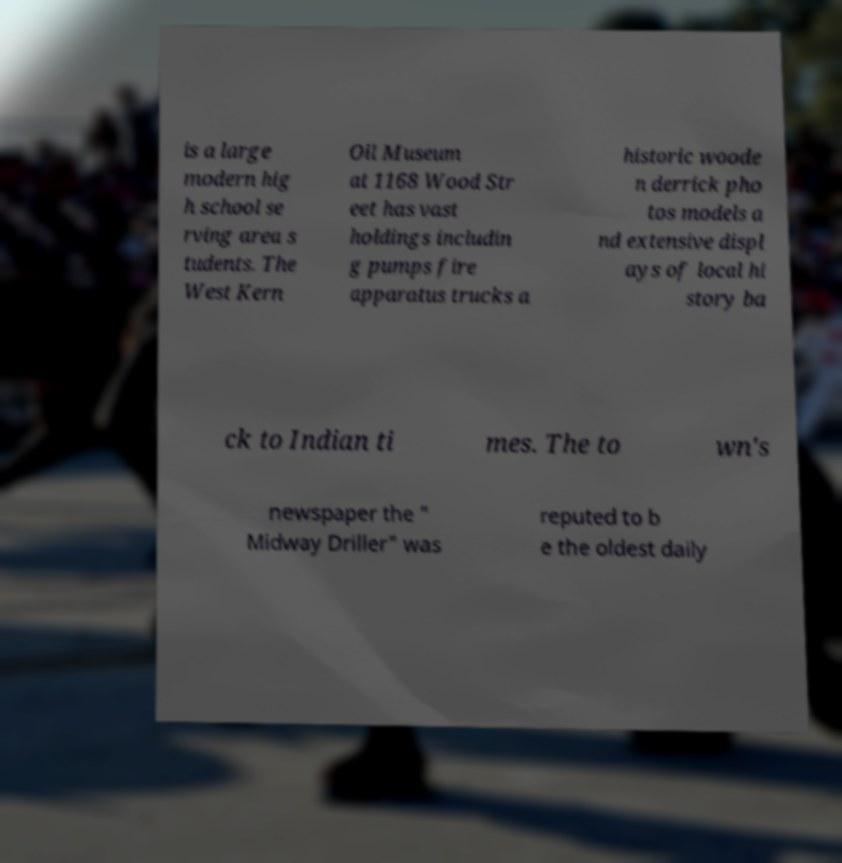Please identify and transcribe the text found in this image. is a large modern hig h school se rving area s tudents. The West Kern Oil Museum at 1168 Wood Str eet has vast holdings includin g pumps fire apparatus trucks a historic woode n derrick pho tos models a nd extensive displ ays of local hi story ba ck to Indian ti mes. The to wn's newspaper the " Midway Driller" was reputed to b e the oldest daily 